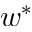Convert formula to latex. <formula><loc_0><loc_0><loc_500><loc_500>w ^ { * }</formula> 